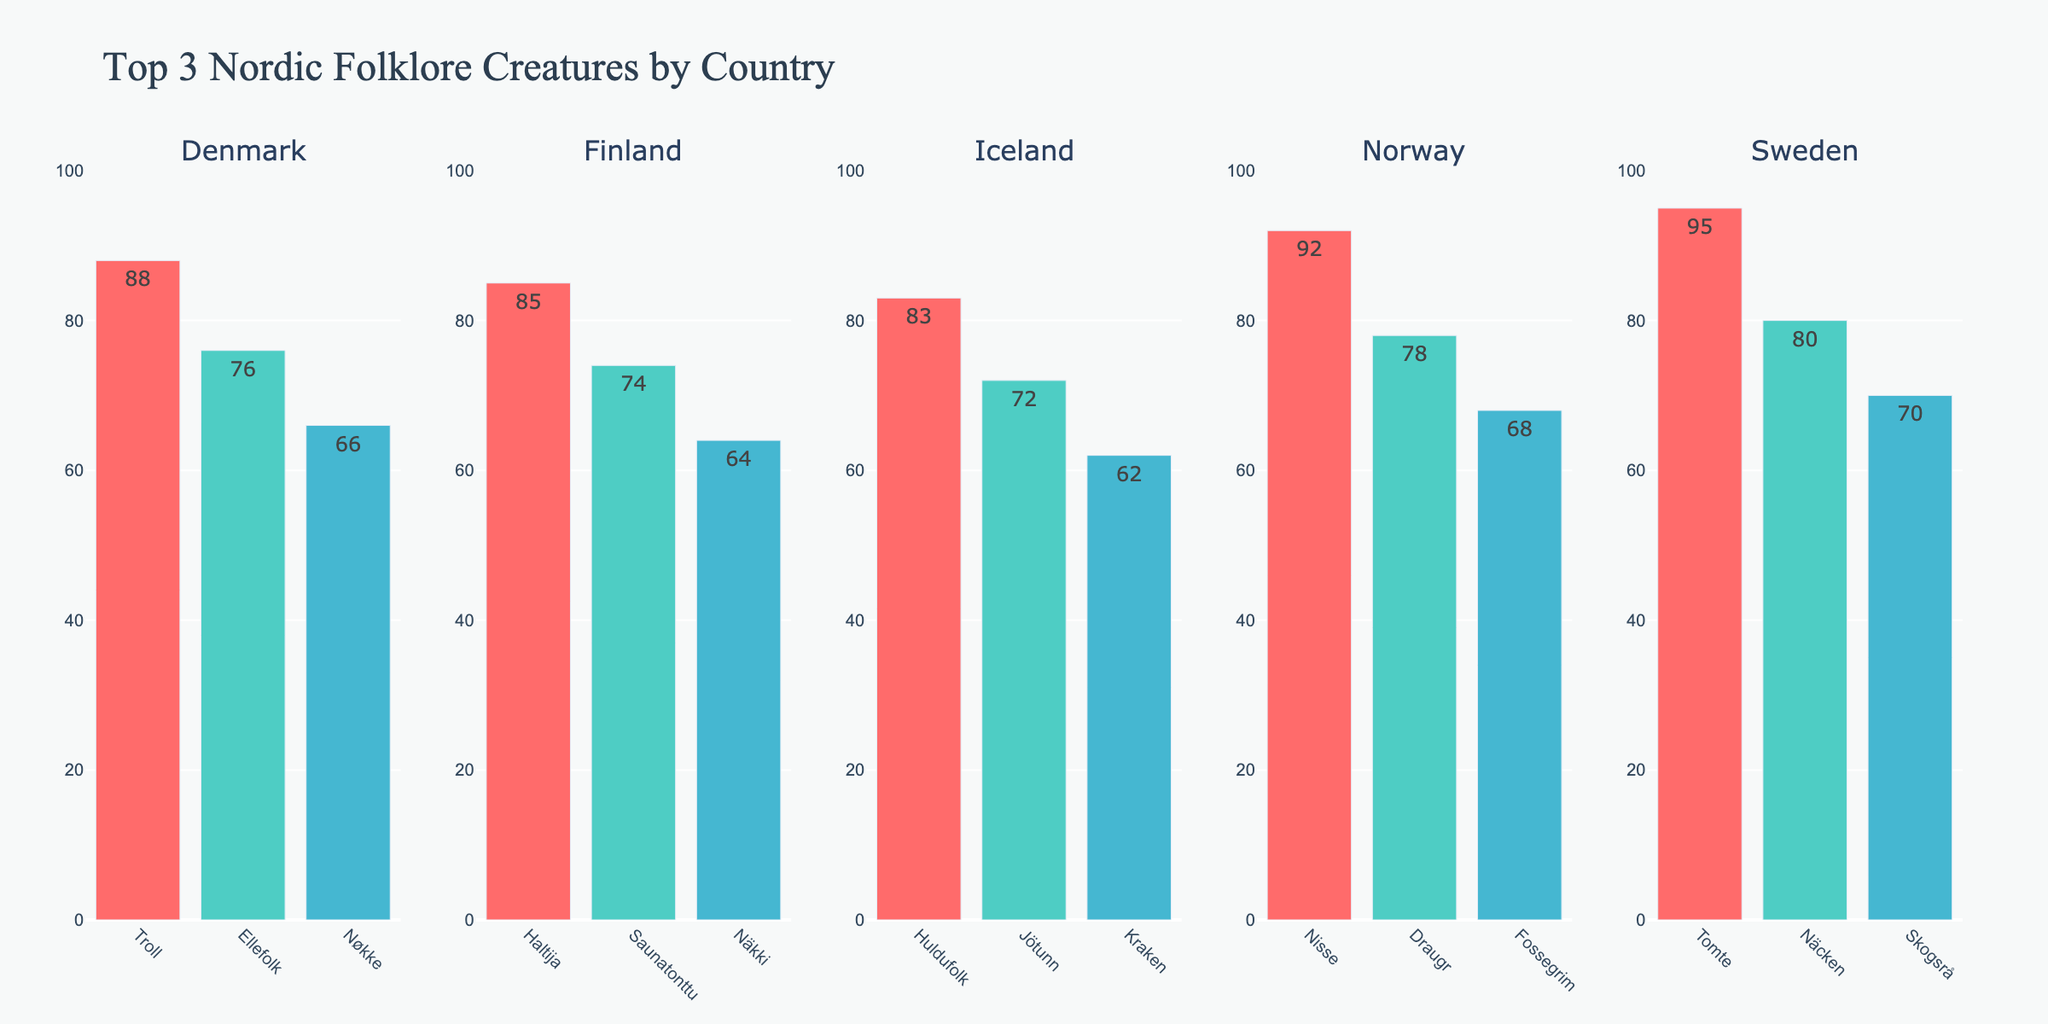Which country has the most popular creature? Sweden has the most popular creature, Tomte, with a popularity score of 95, which is visibly the highest bar in the chart.
Answer: Sweden Which creature has the lowest popularity score in Iceland? The Icelandic creature with the lowest popularity score is Draugr, with a score of 52. It is represented by the shortest bar in the Iceland column.
Answer: Draugr What is the combined popularity score of Näcken and Skogsrå in Sweden? The popularity scores for Näcken and Skogsrå are 80 and 70 respectively. Adding them together results in 80 + 70 = 150.
Answer: 150 How does the popularity of the Troll in Denmark compare to the Nisse in Norway? The popularity score of the Troll in Denmark is 88, while the Nisse in Norway has a score of 92. Therefore, Nisse is more popular than Troll by 92 - 88 = 4 points.
Answer: Nisse is more popular by 4 points Which country has the second highest popularity score for its top creature? Norway has the second highest popularity score for its top creature, Nisse, with a score of 92. This is only 3 points lower than Sweden's top creature, Tomte, which has a score of 95.
Answer: Norway Identify and compare the creatures in Finland and Denmark with the lowest popularity score on the chart. The creatures in Finland and Denmark with the lowest popularity scores are Hiisi (54) and Valravn (56) respectively. Hiisi has the lower score by 56 - 54 = 2 points.
Answer: Hiisi in Finland is 2 points lower Which creatures in the chart have a popularity score less than 60? The creatures with a popularity score of less than 60 are Huldra in Sweden (60), Huldra in Norway (58), Valravn in Denmark (56), Hiisi in Finland (54), and Draugr in Iceland (52). This can be determined by observing the heights of the bars that fall short of the 60 mark.
Answer: Huldra (Sweden), Huldra (Norway), Valravn (Denmark), Hiisi (Finland), Draugr (Iceland) What is the average popularity score of the three most popular creatures in Norway? The three most popular creatures in Norway are Nisse (92), Draugr (78), and Fossegrim (68). The average score is calculated as (92 + 78 + 68) / 3 = 79.33.
Answer: 79.33 